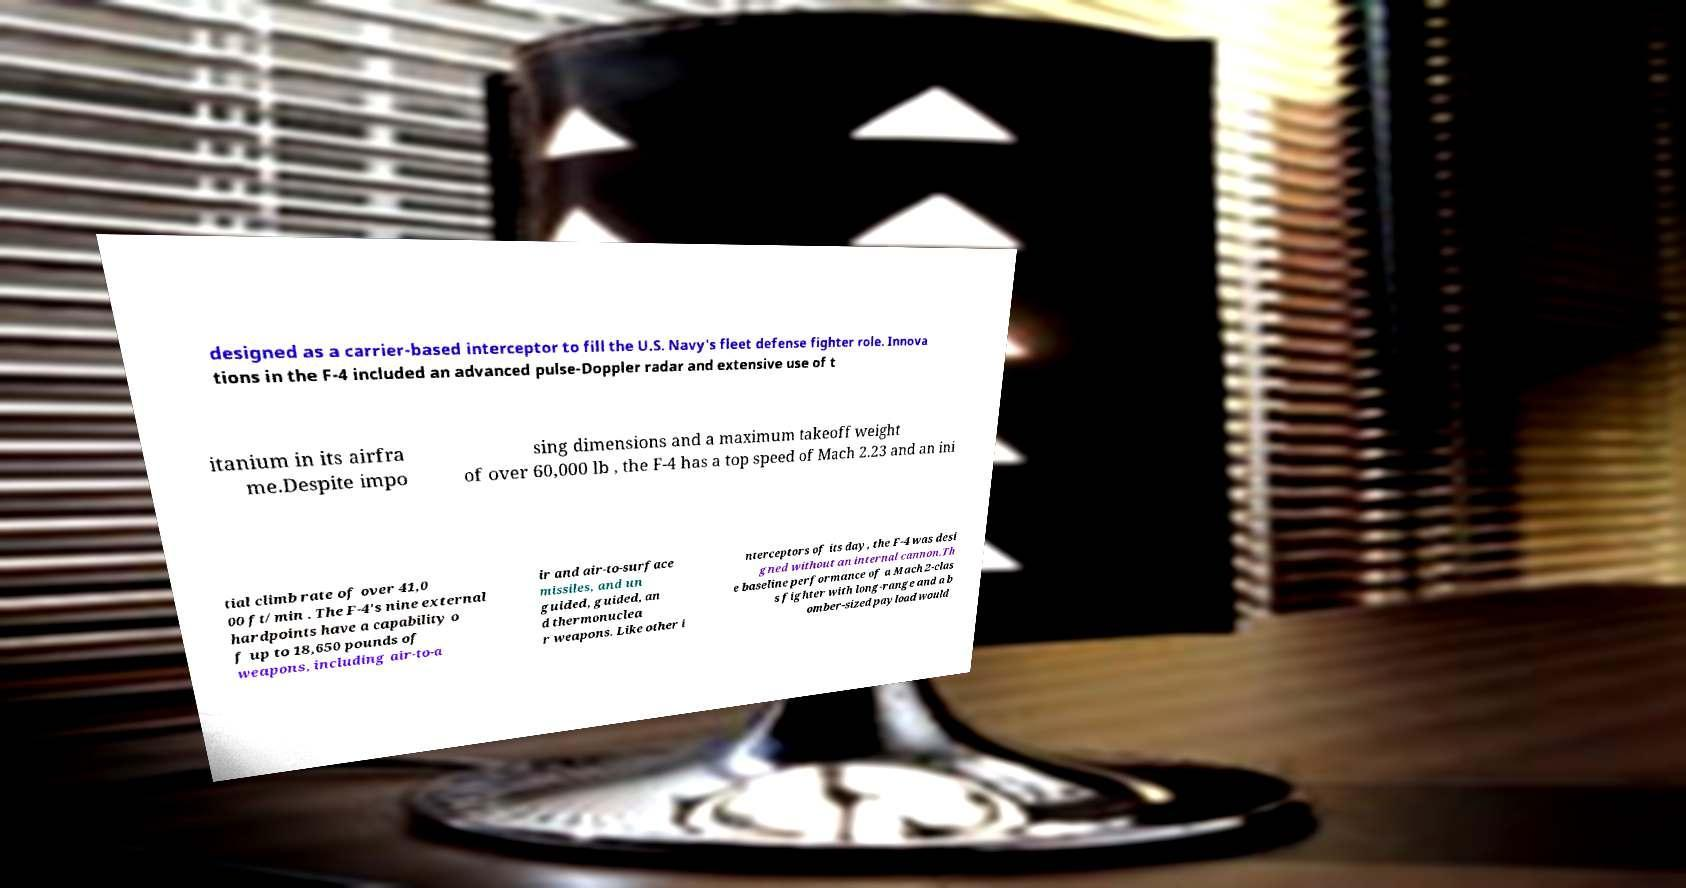Could you extract and type out the text from this image? designed as a carrier-based interceptor to fill the U.S. Navy's fleet defense fighter role. Innova tions in the F-4 included an advanced pulse-Doppler radar and extensive use of t itanium in its airfra me.Despite impo sing dimensions and a maximum takeoff weight of over 60,000 lb , the F-4 has a top speed of Mach 2.23 and an ini tial climb rate of over 41,0 00 ft/min . The F-4's nine external hardpoints have a capability o f up to 18,650 pounds of weapons, including air-to-a ir and air-to-surface missiles, and un guided, guided, an d thermonuclea r weapons. Like other i nterceptors of its day, the F-4 was desi gned without an internal cannon.Th e baseline performance of a Mach 2-clas s fighter with long-range and a b omber-sized payload would 